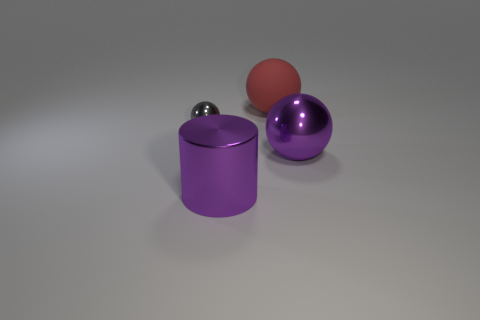Add 4 small cyan blocks. How many objects exist? 8 Subtract all large red spheres. How many spheres are left? 2 Subtract all cylinders. How many objects are left? 3 Subtract all red balls. How many balls are left? 2 Subtract 3 balls. How many balls are left? 0 Subtract all large purple things. Subtract all metallic cylinders. How many objects are left? 1 Add 3 large red rubber objects. How many large red rubber objects are left? 4 Add 2 big red spheres. How many big red spheres exist? 3 Subtract 0 red cubes. How many objects are left? 4 Subtract all blue balls. Subtract all brown cylinders. How many balls are left? 3 